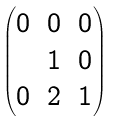Convert formula to latex. <formula><loc_0><loc_0><loc_500><loc_500>\begin{pmatrix} 0 & 0 & 0 \\ & 1 & 0 \\ 0 & 2 & 1 \end{pmatrix}</formula> 